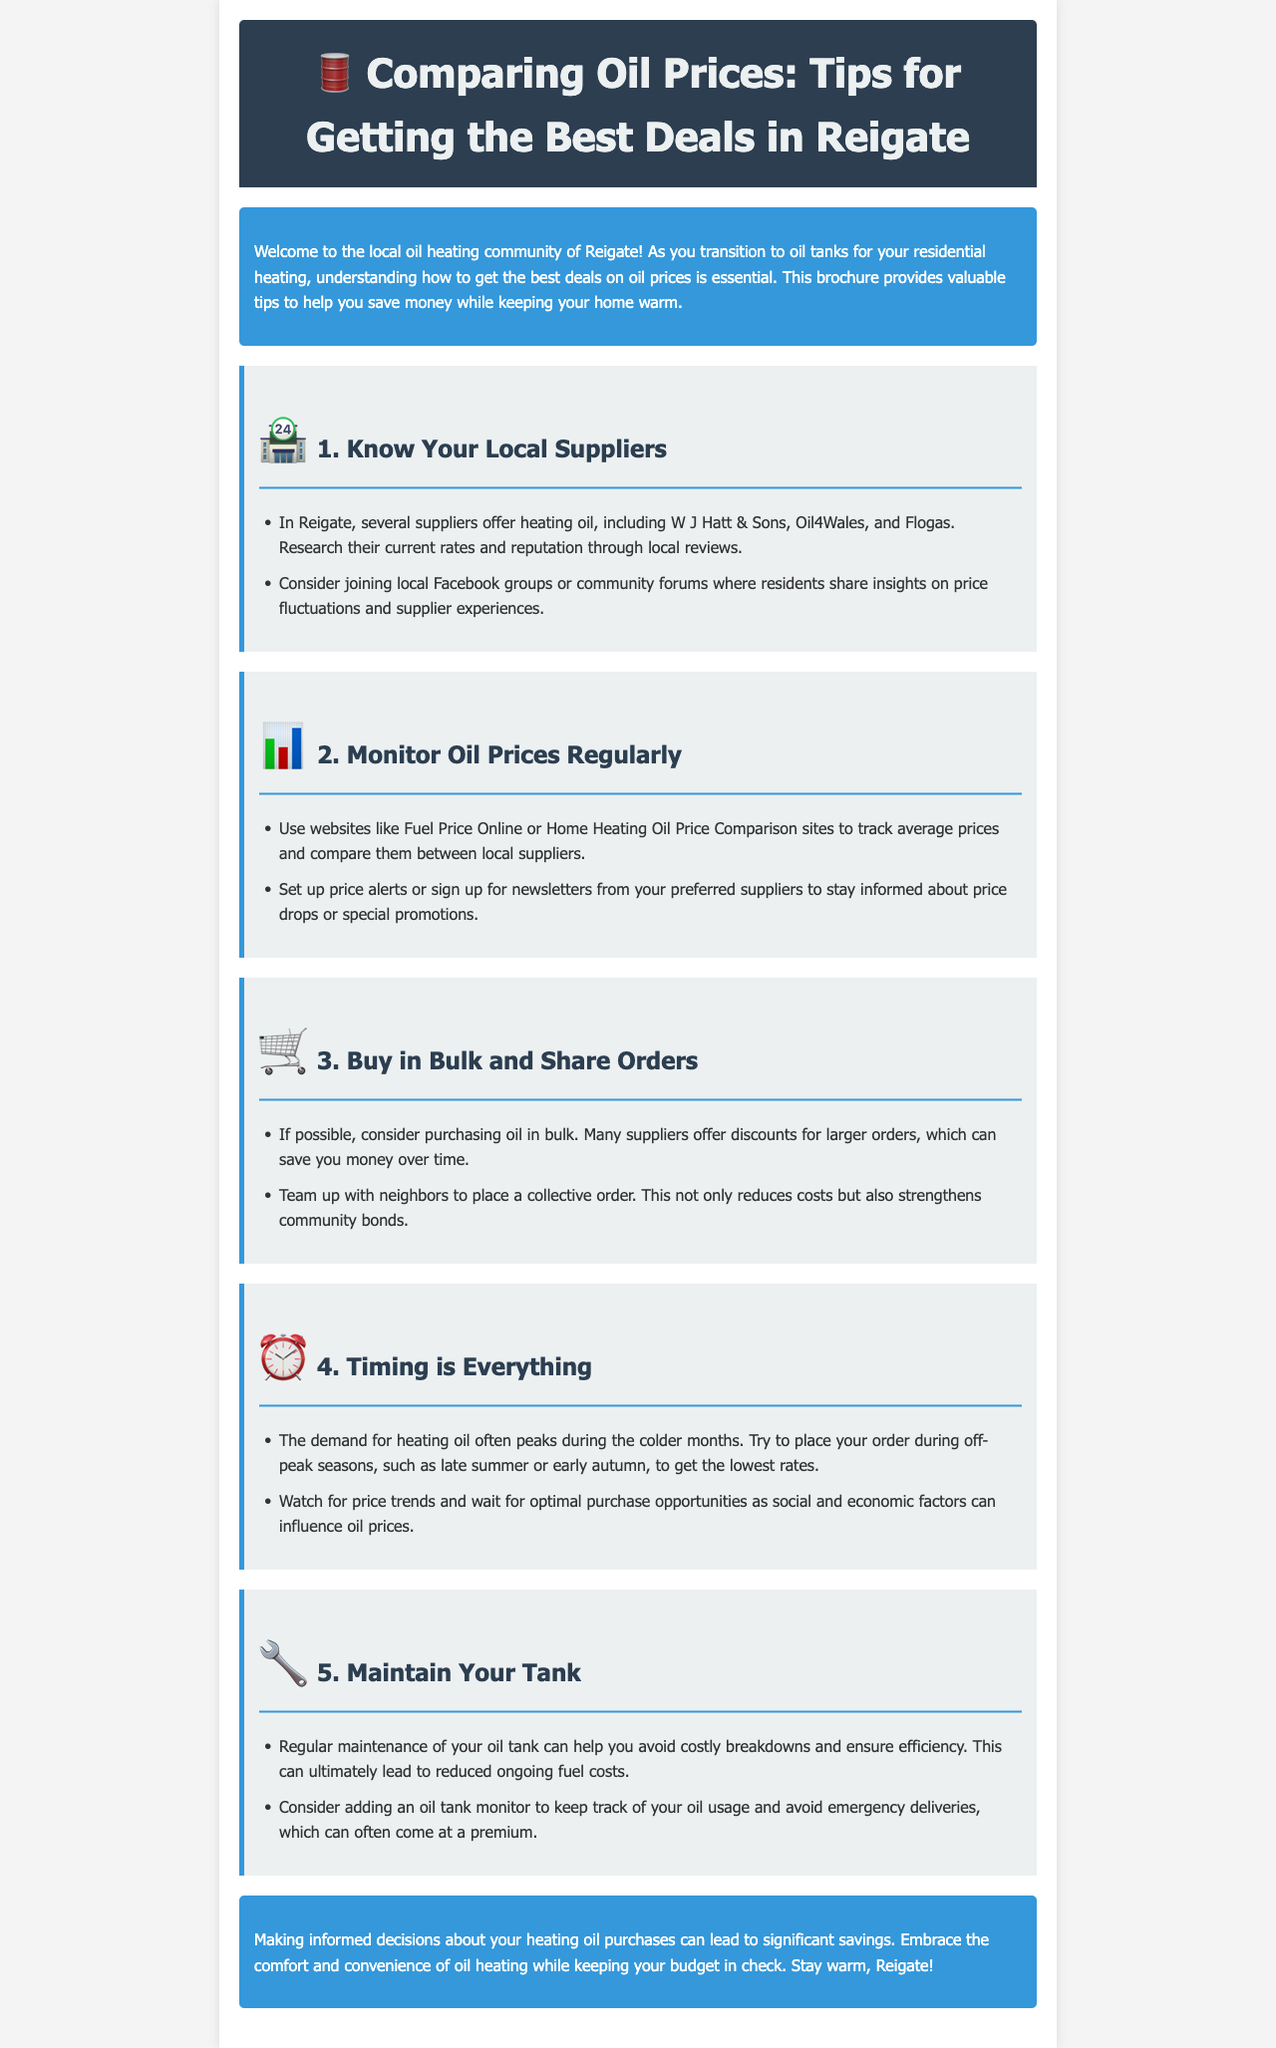What are some local suppliers mentioned? The document lists specific suppliers for heating oil in Reigate, including W J Hatt & Sons, Oil4Wales, and Flogas.
Answer: W J Hatt & Sons, Oil4Wales, Flogas What should you do to monitor oil prices? The brochure recommends using websites like Fuel Price Online or Home Heating Oil Price Comparison sites to track prices and compare them.
Answer: Use websites What can help you save money when buying oil? The document suggests purchasing oil in bulk, which can lead to discounts, and teaming up with neighbors for collective orders.
Answer: Buy in bulk When is the best time to purchase oil? According to the brochure, it discusses placing orders during off-peak seasons, such as late summer or early autumn, to secure lower rates.
Answer: Off-peak seasons What is one way to maintain your oil tank? The document states that regular maintenance can help avoid costly breakdowns and ensure efficiency, contributing to reduced fuel costs.
Answer: Regular maintenance What is a suggested action for tracking oil usage? The brochure recommends adding an oil tank monitor to keep track of oil usage and avoid emergency deliveries.
Answer: Add an oil tank monitor Where can you find rewards for price fluctuations? The document encourages joining local Facebook groups or community forums for insights on price fluctuations and supplier experiences.
Answer: Facebook groups What advice does the brochure give regarding supplier rates? It emphasizes researching current rates and reputation of suppliers through local reviews for informed decision-making.
Answer: Research supplier rates What is the closing message about making informed decisions? The document concludes by stating that informed decisions can lead to significant savings, allowing you to stay warm while keeping your budget in check.
Answer: Significant savings 